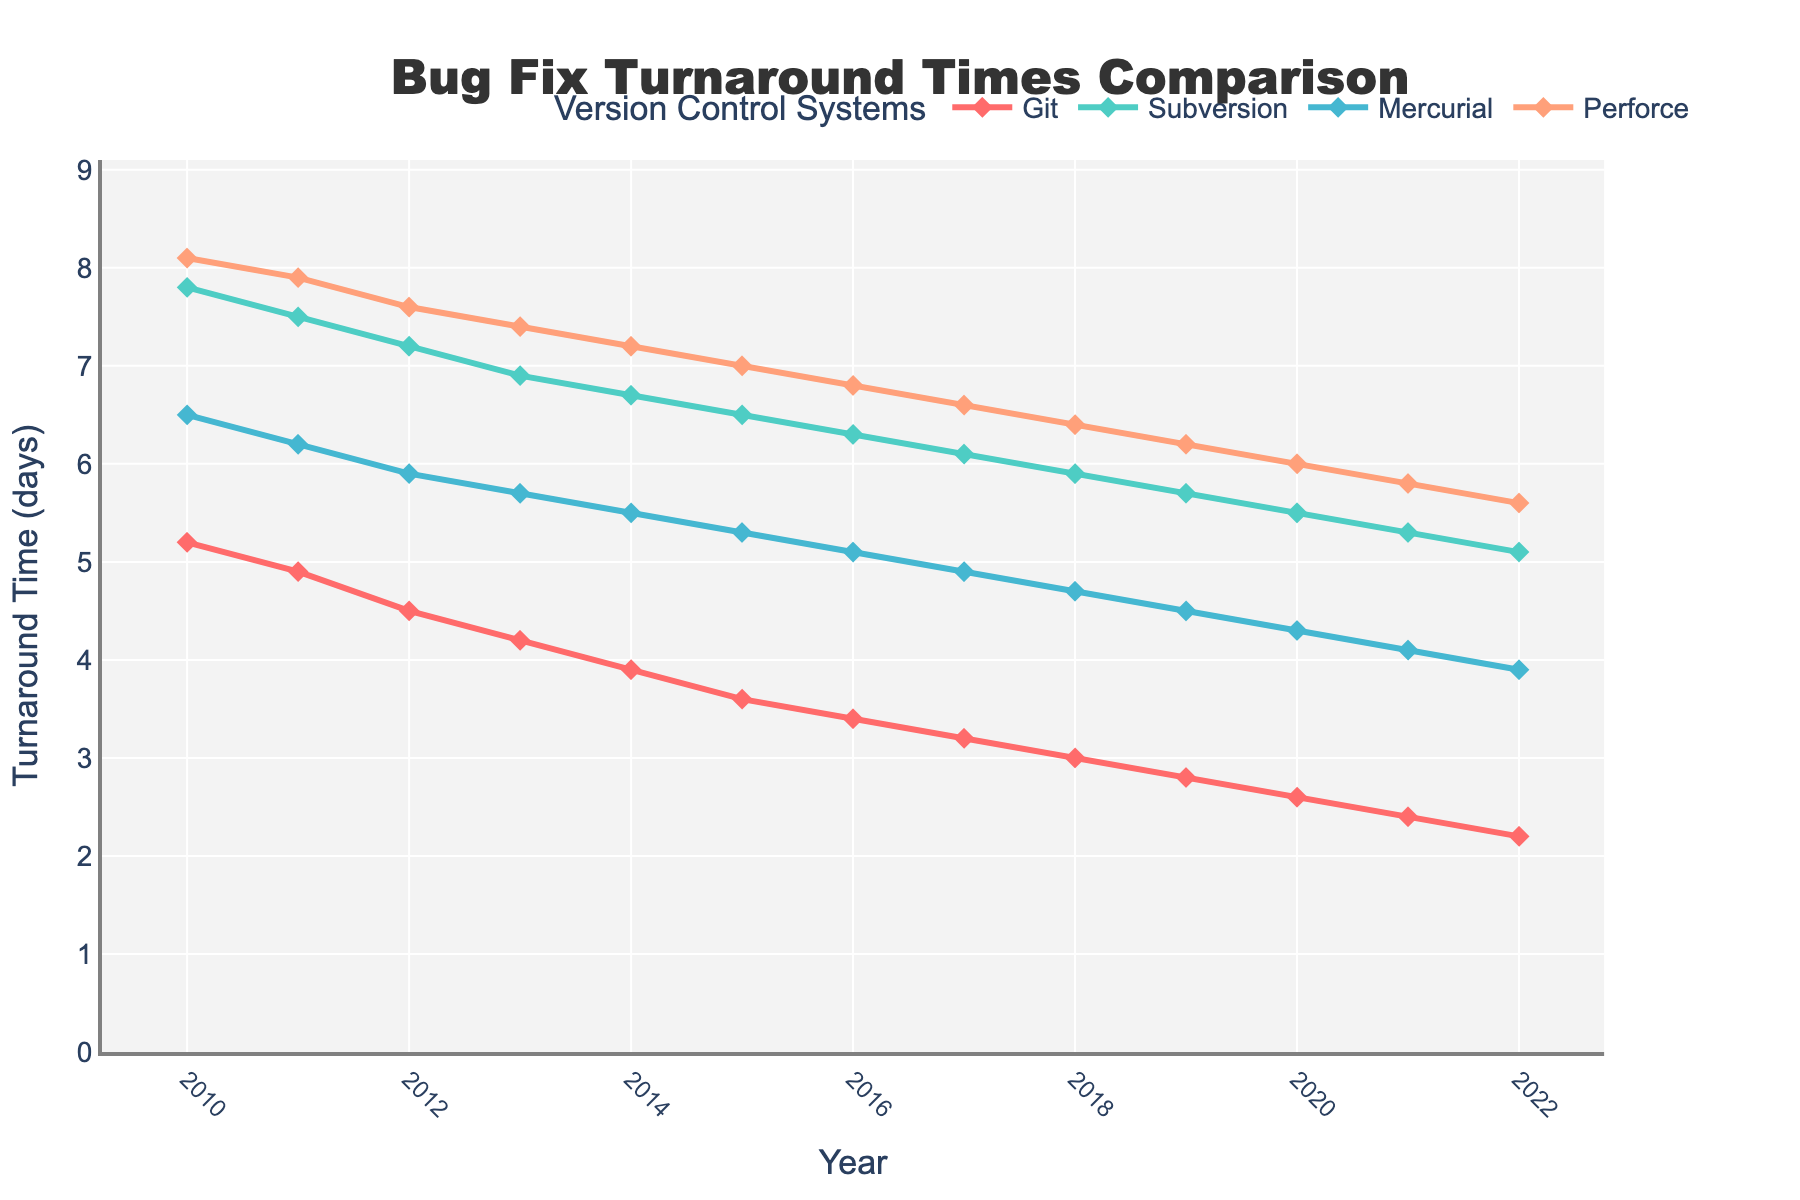What's the trend in bug fix turnaround times for Git from 2010 to 2022? Git shows a consistent decline in bug fix turnaround times from 2010 to 2022, decreasing from 5.2 days in 2010 to 2.2 days in 2022.
Answer: Consistent decline Which version control system had the highest bug fix turnaround time in 2015? In 2015, Perforce had the highest bug fix turnaround time at 7.0 days.
Answer: Perforce How does the average bug fix turnaround time for Subversion and Mercurial compare over the entire period? First, find the average for each:
- Subversion: (7.8 + 7.5 + 7.2 + 6.9 + 6.7 + 6.5 + 6.3 + 6.1 + 5.9 + 5.7 + 5.5 + 5.3 + 5.1) / 13 ≈ 6.34 days
- Mercurial: (6.5 + 6.2 + 5.9 + 5.7 + 5.5 + 5.3 + 5.1 + 4.9 + 4.7 + 4.5 + 4.3 + 4.1 + 3.9) / 13 ≈ 5.10 days
Comparison: Subversion has a higher average bug fix turnaround time than Mercurial.
Answer: Subversion's average is higher In which year did Git first achieve a turnaround time of less than 3 days? Git achieved a turnaround time of less than 3 days for the first time in 2018, with 3.0 days.
Answer: 2018 What is the difference in bug fix turnaround times between Git and Perforce in 2013? In 2013, Git had a turnaround time of 4.2 days and Perforce had 7.4 days. The difference is 7.4 - 4.2 = 3.2 days.
Answer: 3.2 days What can you say about Perforce's trend over the years compared to Mercurial's? Both Perforce and Mercurial show a decreasing trend over the years. However, Perforce's decline is less steep compared to Mercurial's.
Answer: Both decrease, Mercurial steeper By how much did Subversion's bug fix turnaround time decrease from 2010 to 2022? In 2010, Subversion had a turnaround time of 7.8 days, and in 2022 it was 5.1 days. The decrease is 7.8 - 5.1 = 2.7 days.
Answer: 2.7 days Which version control system had the most significant improvement in turnaround time from 2010 to 2022? From 2010 to 2022, Git showed the most significant improvement, decreasing from 5.2 days to 2.2 days, an improvement of 3.0 days.
Answer: Git 